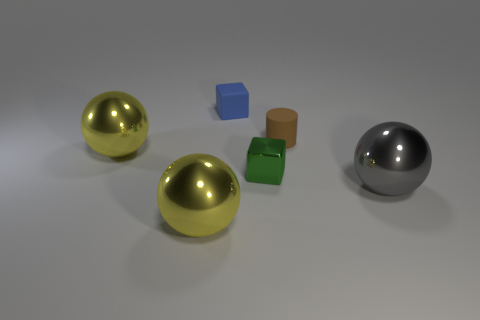What could be the sizes of these objects in relation to each other? Judging by their relative sizes in the image, the two spheres are likely the largest objects, followed by the green cube and the small brown cylinder. The blue object appears to be the smallest. However, without additional context or reference, absolute sizes are indeterminate.  Could you estimate the physical properties of the surfaces of these objects? The surfaces of the objects vary; the spheres look metallic and smooth, reflecting light sharply. The green cube and brown cylinder look to have a more matte finish, suggesting a possibly rougher texture like plastic or cardboard, which diffuses light. The blue object has a less reflective, possibly paper-like surface. 